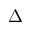Convert formula to latex. <formula><loc_0><loc_0><loc_500><loc_500>\Delta</formula> 